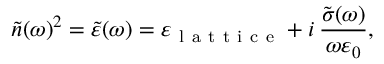<formula> <loc_0><loc_0><loc_500><loc_500>\tilde { n } ( \omega ) ^ { 2 } = \tilde { \varepsilon } ( \omega ) = \varepsilon _ { l a t t i c e } + i \, \frac { \tilde { \sigma } ( \omega ) } { \omega \varepsilon _ { 0 } } ,</formula> 